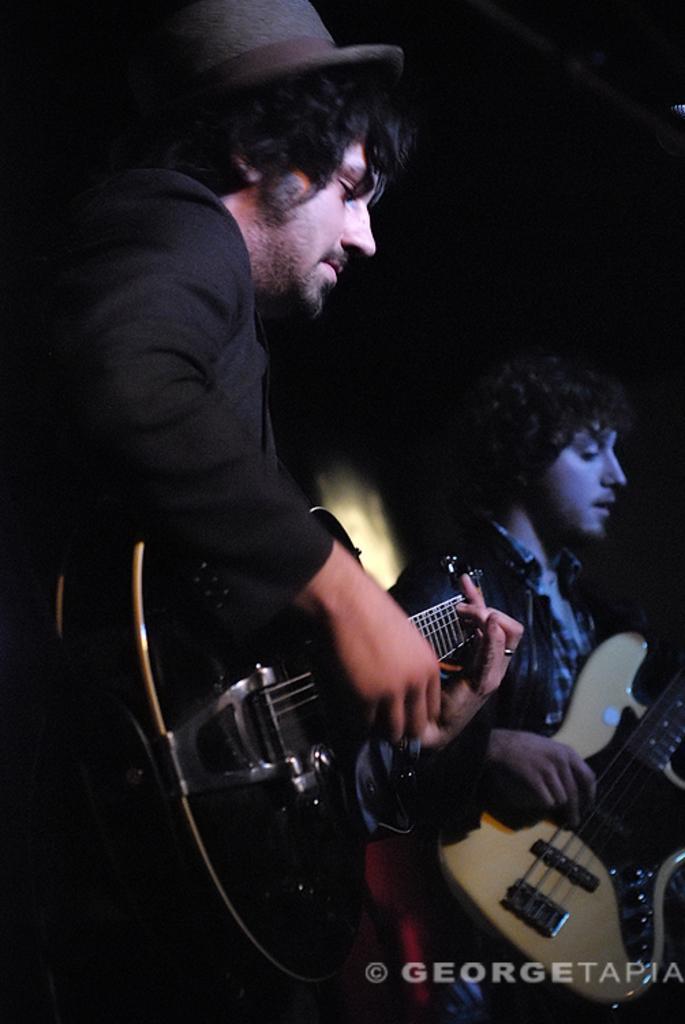How would you summarize this image in a sentence or two? In this picture we can see two men. The men in the front is wearing a black dress and playing the guitar. And he is wearing hat on his head. The men at the right side is also playing a guitar. 